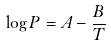Convert formula to latex. <formula><loc_0><loc_0><loc_500><loc_500>\log P = A - \frac { B } { T }</formula> 